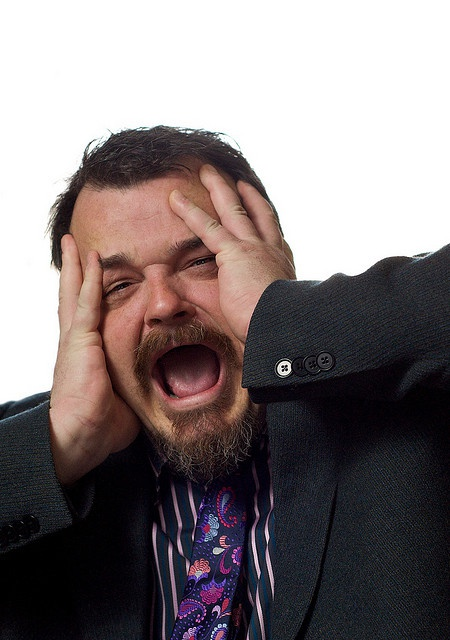Describe the objects in this image and their specific colors. I can see people in black, white, tan, brown, and maroon tones and tie in white, black, navy, and purple tones in this image. 